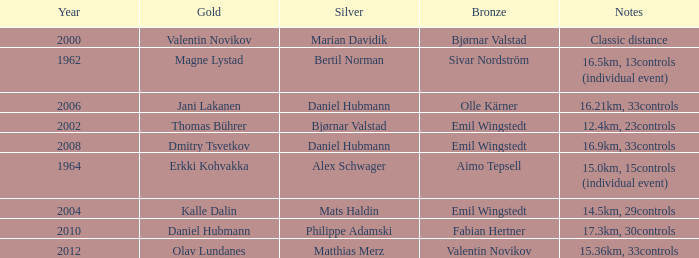WHAT YEAR HAS A BRONZE OF VALENTIN NOVIKOV? 2012.0. 